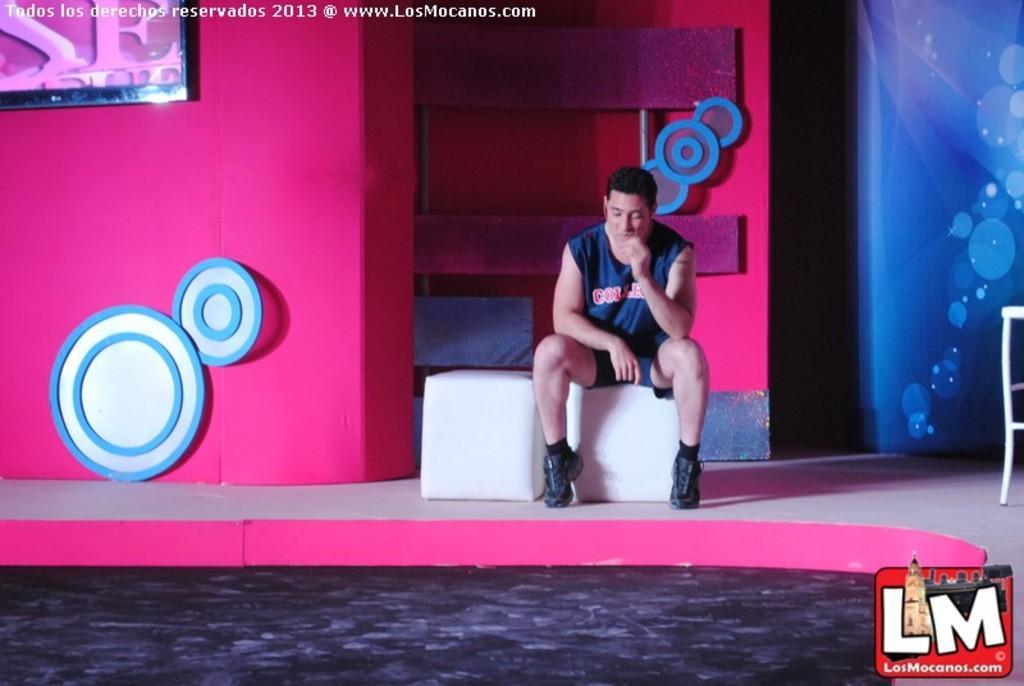Describe this image in one or two sentences. In this image there is a man sitting on an object, there is a person truncated towards the right of the image, at the background of the image there is the wall truncated, there are objects on the wall, there is a television truncated towards the top of the image, there is text, at the bottom of the image there is the floor truncated. 